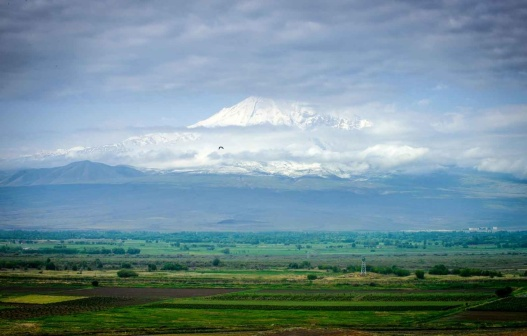Can you describe the main features of this image for me? The image showcases an awe-inspiring panorama of a vast landscape. At its heart lies a grand mountain, whose peak is enveloped in a pristine, snowy mantle. This majestic peak is partly shrouded by a delicate veil of clouds, adding a touch of mystique to its imposing presence.

In contrast, the foreground reveals a lush, green valley. It's a mosaic of rich green fields interspersed with patches of trees, each contributing vibrant colors that sharply contrast the snowy backdrop. 

Above, the sky is a brilliant blue canvas adorned with scattered, fluffy white clouds, suggesting a day of calm weather that perfectly complements the serene beauty of the scene.

The elements in the image are in perfect harmony, with the snowy mountain, green valley, and blue sky each contributing to the tranquil and majestic atmosphere. The absence of any text ensures that the viewer can fully immerse themselves in the natural splendor presented. This image is a stunning representation of nature's breathtaking beauty, all captured within a single, powerful frame. 